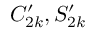<formula> <loc_0><loc_0><loc_500><loc_500>C _ { 2 k } ^ { \prime } , S _ { 2 k } ^ { \prime }</formula> 